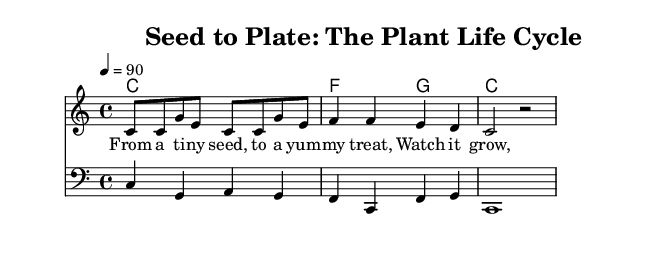What is the key signature of this music? The key signature is indicated at the beginning of the staff and shows there are no sharps or flats, which defines it as C major.
Answer: C major What is the time signature of the music? The time signature appears toward the beginning of the music and is 4/4, indicating there are four beats in a measure.
Answer: 4/4 What is the tempo marking indicated in the piece? The tempo marking, which suggests how fast the music should be played, is noted as "4 = 90" indicating that each quarter note should be played at a speed of 90 beats per minute.
Answer: 90 How many measures are in the melody section? By counting the number of notated bars in the melody part, there are four measures present in the melody.
Answer: 4 What is the primary theme of the lyrics? The lyrics reflect the topic of growth and transformation from a seed to a consumable treat, highlighting the life cycle of plants.
Answer: Growth from seed to treat What is the chord for the first measure? The chord indicated in the harmonies section for the first measure is C major, as it appears dedicated to that specific measure at the start of the harmonies.
Answer: C What type of music is this piece categorized as? Based on the style, structure, and lyrical content, this piece is categorized specifically as a rap, as it utilizes rhythmic patterns and urban language to convey its educational message.
Answer: Rap 